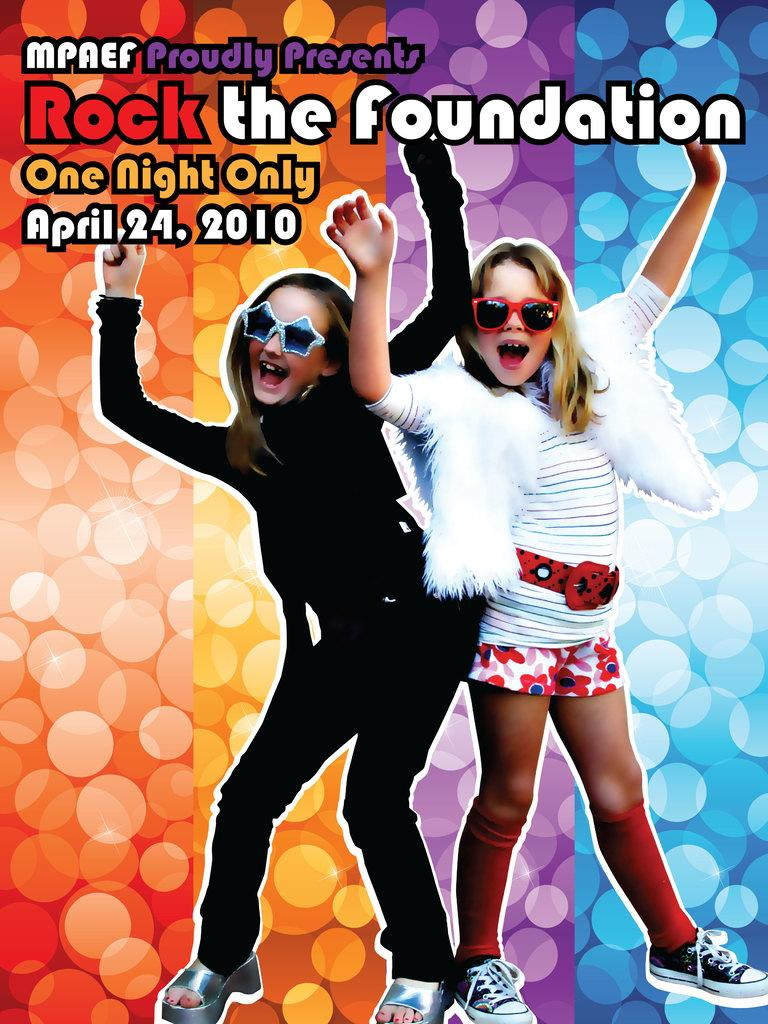What is featured in the image? There is a poster in the image. Are there any other subjects or objects in the image besides the poster? Yes, there are people in the image. Can you describe the text at the top of the image? There is text at the top of the image. What type of oil is being used to cook the stew in the image? There is no oil or stew present in the image; it features a poster and people. 